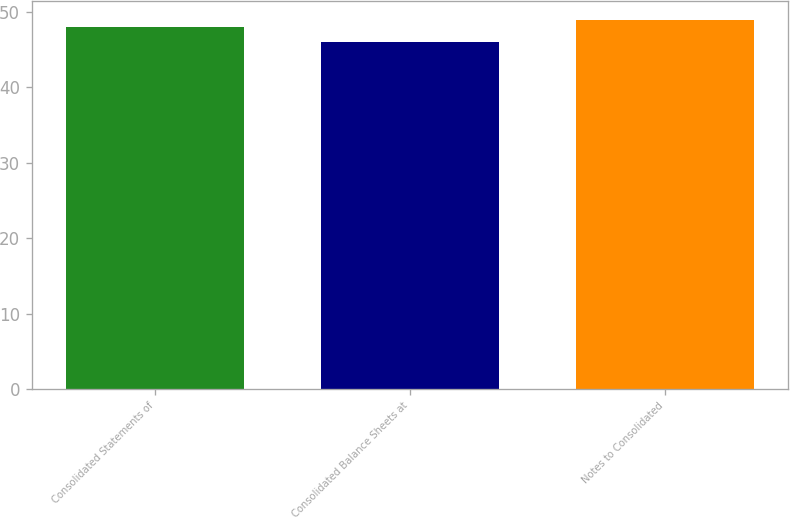Convert chart to OTSL. <chart><loc_0><loc_0><loc_500><loc_500><bar_chart><fcel>Consolidated Statements of<fcel>Consolidated Balance Sheets at<fcel>Notes to Consolidated<nl><fcel>48<fcel>46<fcel>49<nl></chart> 